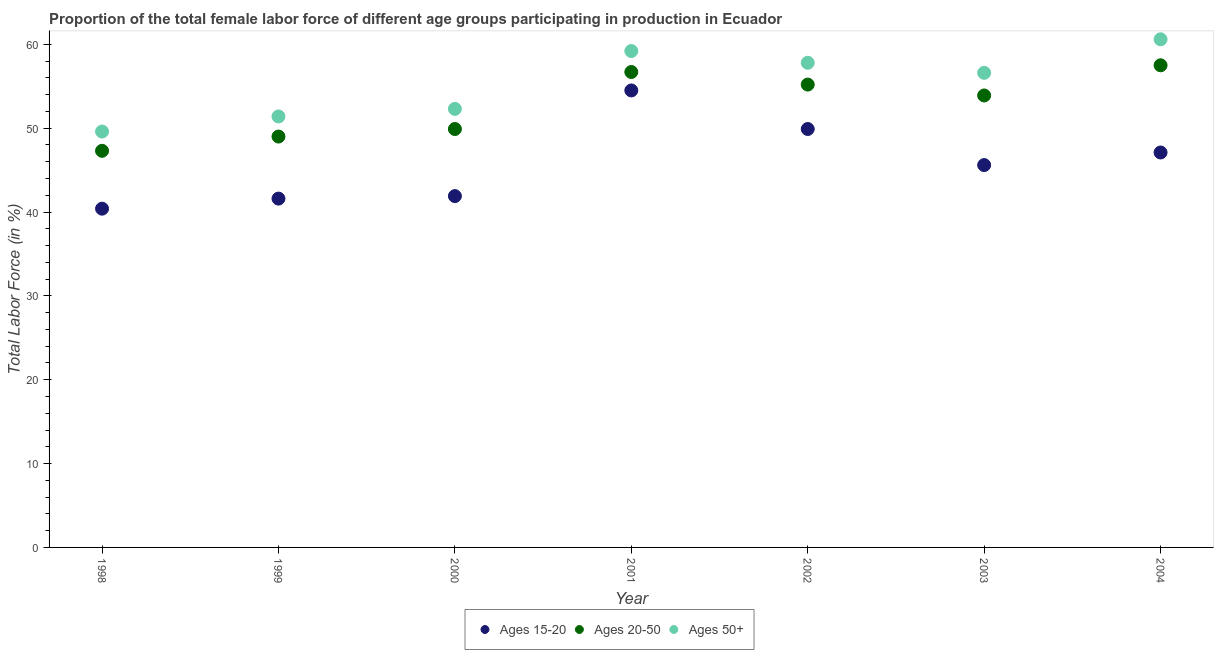Is the number of dotlines equal to the number of legend labels?
Ensure brevity in your answer.  Yes. What is the percentage of female labor force above age 50 in 1998?
Offer a very short reply. 49.6. Across all years, what is the maximum percentage of female labor force within the age group 20-50?
Provide a succinct answer. 57.5. Across all years, what is the minimum percentage of female labor force within the age group 20-50?
Give a very brief answer. 47.3. In which year was the percentage of female labor force above age 50 maximum?
Offer a terse response. 2004. In which year was the percentage of female labor force within the age group 15-20 minimum?
Offer a very short reply. 1998. What is the total percentage of female labor force above age 50 in the graph?
Make the answer very short. 387.5. What is the difference between the percentage of female labor force within the age group 20-50 in 1998 and that in 2002?
Offer a very short reply. -7.9. What is the difference between the percentage of female labor force above age 50 in 2000 and the percentage of female labor force within the age group 20-50 in 2004?
Your response must be concise. -5.2. What is the average percentage of female labor force within the age group 15-20 per year?
Give a very brief answer. 45.86. In the year 2001, what is the difference between the percentage of female labor force within the age group 20-50 and percentage of female labor force above age 50?
Keep it short and to the point. -2.5. What is the ratio of the percentage of female labor force above age 50 in 2002 to that in 2004?
Give a very brief answer. 0.95. What is the difference between the highest and the second highest percentage of female labor force within the age group 15-20?
Ensure brevity in your answer.  4.6. In how many years, is the percentage of female labor force within the age group 15-20 greater than the average percentage of female labor force within the age group 15-20 taken over all years?
Your response must be concise. 3. Is the percentage of female labor force within the age group 20-50 strictly greater than the percentage of female labor force above age 50 over the years?
Ensure brevity in your answer.  No. How many dotlines are there?
Provide a short and direct response. 3. How many years are there in the graph?
Provide a short and direct response. 7. What is the difference between two consecutive major ticks on the Y-axis?
Your answer should be very brief. 10. Are the values on the major ticks of Y-axis written in scientific E-notation?
Provide a short and direct response. No. How many legend labels are there?
Provide a succinct answer. 3. What is the title of the graph?
Give a very brief answer. Proportion of the total female labor force of different age groups participating in production in Ecuador. Does "Capital account" appear as one of the legend labels in the graph?
Provide a succinct answer. No. What is the Total Labor Force (in %) in Ages 15-20 in 1998?
Provide a succinct answer. 40.4. What is the Total Labor Force (in %) in Ages 20-50 in 1998?
Make the answer very short. 47.3. What is the Total Labor Force (in %) in Ages 50+ in 1998?
Offer a terse response. 49.6. What is the Total Labor Force (in %) of Ages 15-20 in 1999?
Ensure brevity in your answer.  41.6. What is the Total Labor Force (in %) of Ages 20-50 in 1999?
Offer a terse response. 49. What is the Total Labor Force (in %) in Ages 50+ in 1999?
Ensure brevity in your answer.  51.4. What is the Total Labor Force (in %) in Ages 15-20 in 2000?
Keep it short and to the point. 41.9. What is the Total Labor Force (in %) in Ages 20-50 in 2000?
Offer a very short reply. 49.9. What is the Total Labor Force (in %) in Ages 50+ in 2000?
Keep it short and to the point. 52.3. What is the Total Labor Force (in %) in Ages 15-20 in 2001?
Your answer should be compact. 54.5. What is the Total Labor Force (in %) in Ages 20-50 in 2001?
Keep it short and to the point. 56.7. What is the Total Labor Force (in %) of Ages 50+ in 2001?
Keep it short and to the point. 59.2. What is the Total Labor Force (in %) of Ages 15-20 in 2002?
Provide a succinct answer. 49.9. What is the Total Labor Force (in %) in Ages 20-50 in 2002?
Your response must be concise. 55.2. What is the Total Labor Force (in %) of Ages 50+ in 2002?
Offer a very short reply. 57.8. What is the Total Labor Force (in %) in Ages 15-20 in 2003?
Ensure brevity in your answer.  45.6. What is the Total Labor Force (in %) in Ages 20-50 in 2003?
Provide a short and direct response. 53.9. What is the Total Labor Force (in %) of Ages 50+ in 2003?
Provide a succinct answer. 56.6. What is the Total Labor Force (in %) in Ages 15-20 in 2004?
Offer a terse response. 47.1. What is the Total Labor Force (in %) in Ages 20-50 in 2004?
Offer a terse response. 57.5. What is the Total Labor Force (in %) in Ages 50+ in 2004?
Your response must be concise. 60.6. Across all years, what is the maximum Total Labor Force (in %) in Ages 15-20?
Provide a succinct answer. 54.5. Across all years, what is the maximum Total Labor Force (in %) of Ages 20-50?
Give a very brief answer. 57.5. Across all years, what is the maximum Total Labor Force (in %) in Ages 50+?
Your answer should be compact. 60.6. Across all years, what is the minimum Total Labor Force (in %) in Ages 15-20?
Provide a short and direct response. 40.4. Across all years, what is the minimum Total Labor Force (in %) in Ages 20-50?
Your answer should be compact. 47.3. Across all years, what is the minimum Total Labor Force (in %) in Ages 50+?
Keep it short and to the point. 49.6. What is the total Total Labor Force (in %) of Ages 15-20 in the graph?
Ensure brevity in your answer.  321. What is the total Total Labor Force (in %) in Ages 20-50 in the graph?
Your response must be concise. 369.5. What is the total Total Labor Force (in %) in Ages 50+ in the graph?
Your answer should be compact. 387.5. What is the difference between the Total Labor Force (in %) in Ages 15-20 in 1998 and that in 1999?
Your response must be concise. -1.2. What is the difference between the Total Labor Force (in %) in Ages 50+ in 1998 and that in 1999?
Offer a terse response. -1.8. What is the difference between the Total Labor Force (in %) in Ages 15-20 in 1998 and that in 2001?
Offer a terse response. -14.1. What is the difference between the Total Labor Force (in %) in Ages 20-50 in 1998 and that in 2001?
Ensure brevity in your answer.  -9.4. What is the difference between the Total Labor Force (in %) of Ages 15-20 in 1998 and that in 2002?
Make the answer very short. -9.5. What is the difference between the Total Labor Force (in %) of Ages 20-50 in 1998 and that in 2002?
Provide a succinct answer. -7.9. What is the difference between the Total Labor Force (in %) in Ages 50+ in 1998 and that in 2002?
Provide a short and direct response. -8.2. What is the difference between the Total Labor Force (in %) of Ages 15-20 in 1998 and that in 2003?
Provide a succinct answer. -5.2. What is the difference between the Total Labor Force (in %) of Ages 15-20 in 1998 and that in 2004?
Your response must be concise. -6.7. What is the difference between the Total Labor Force (in %) of Ages 50+ in 1998 and that in 2004?
Ensure brevity in your answer.  -11. What is the difference between the Total Labor Force (in %) of Ages 20-50 in 1999 and that in 2000?
Provide a short and direct response. -0.9. What is the difference between the Total Labor Force (in %) of Ages 20-50 in 1999 and that in 2001?
Make the answer very short. -7.7. What is the difference between the Total Labor Force (in %) in Ages 20-50 in 1999 and that in 2002?
Provide a short and direct response. -6.2. What is the difference between the Total Labor Force (in %) in Ages 50+ in 1999 and that in 2002?
Ensure brevity in your answer.  -6.4. What is the difference between the Total Labor Force (in %) of Ages 15-20 in 1999 and that in 2003?
Make the answer very short. -4. What is the difference between the Total Labor Force (in %) in Ages 50+ in 1999 and that in 2004?
Give a very brief answer. -9.2. What is the difference between the Total Labor Force (in %) in Ages 15-20 in 2000 and that in 2001?
Make the answer very short. -12.6. What is the difference between the Total Labor Force (in %) of Ages 15-20 in 2000 and that in 2002?
Your answer should be compact. -8. What is the difference between the Total Labor Force (in %) in Ages 20-50 in 2000 and that in 2002?
Offer a very short reply. -5.3. What is the difference between the Total Labor Force (in %) of Ages 50+ in 2000 and that in 2003?
Ensure brevity in your answer.  -4.3. What is the difference between the Total Labor Force (in %) in Ages 15-20 in 2000 and that in 2004?
Give a very brief answer. -5.2. What is the difference between the Total Labor Force (in %) of Ages 20-50 in 2000 and that in 2004?
Offer a terse response. -7.6. What is the difference between the Total Labor Force (in %) of Ages 20-50 in 2001 and that in 2002?
Give a very brief answer. 1.5. What is the difference between the Total Labor Force (in %) of Ages 50+ in 2001 and that in 2002?
Your answer should be compact. 1.4. What is the difference between the Total Labor Force (in %) of Ages 20-50 in 2001 and that in 2003?
Your answer should be compact. 2.8. What is the difference between the Total Labor Force (in %) of Ages 50+ in 2001 and that in 2003?
Your response must be concise. 2.6. What is the difference between the Total Labor Force (in %) in Ages 20-50 in 2001 and that in 2004?
Offer a very short reply. -0.8. What is the difference between the Total Labor Force (in %) in Ages 50+ in 2001 and that in 2004?
Ensure brevity in your answer.  -1.4. What is the difference between the Total Labor Force (in %) of Ages 15-20 in 2002 and that in 2003?
Offer a terse response. 4.3. What is the difference between the Total Labor Force (in %) in Ages 50+ in 2002 and that in 2003?
Give a very brief answer. 1.2. What is the difference between the Total Labor Force (in %) of Ages 15-20 in 2003 and that in 2004?
Give a very brief answer. -1.5. What is the difference between the Total Labor Force (in %) in Ages 50+ in 2003 and that in 2004?
Provide a succinct answer. -4. What is the difference between the Total Labor Force (in %) of Ages 15-20 in 1998 and the Total Labor Force (in %) of Ages 20-50 in 1999?
Your response must be concise. -8.6. What is the difference between the Total Labor Force (in %) of Ages 15-20 in 1998 and the Total Labor Force (in %) of Ages 50+ in 1999?
Give a very brief answer. -11. What is the difference between the Total Labor Force (in %) in Ages 15-20 in 1998 and the Total Labor Force (in %) in Ages 50+ in 2000?
Offer a very short reply. -11.9. What is the difference between the Total Labor Force (in %) of Ages 15-20 in 1998 and the Total Labor Force (in %) of Ages 20-50 in 2001?
Your answer should be very brief. -16.3. What is the difference between the Total Labor Force (in %) in Ages 15-20 in 1998 and the Total Labor Force (in %) in Ages 50+ in 2001?
Make the answer very short. -18.8. What is the difference between the Total Labor Force (in %) in Ages 20-50 in 1998 and the Total Labor Force (in %) in Ages 50+ in 2001?
Provide a succinct answer. -11.9. What is the difference between the Total Labor Force (in %) in Ages 15-20 in 1998 and the Total Labor Force (in %) in Ages 20-50 in 2002?
Make the answer very short. -14.8. What is the difference between the Total Labor Force (in %) in Ages 15-20 in 1998 and the Total Labor Force (in %) in Ages 50+ in 2002?
Give a very brief answer. -17.4. What is the difference between the Total Labor Force (in %) of Ages 20-50 in 1998 and the Total Labor Force (in %) of Ages 50+ in 2002?
Provide a short and direct response. -10.5. What is the difference between the Total Labor Force (in %) in Ages 15-20 in 1998 and the Total Labor Force (in %) in Ages 20-50 in 2003?
Your answer should be very brief. -13.5. What is the difference between the Total Labor Force (in %) in Ages 15-20 in 1998 and the Total Labor Force (in %) in Ages 50+ in 2003?
Your answer should be compact. -16.2. What is the difference between the Total Labor Force (in %) in Ages 20-50 in 1998 and the Total Labor Force (in %) in Ages 50+ in 2003?
Provide a short and direct response. -9.3. What is the difference between the Total Labor Force (in %) of Ages 15-20 in 1998 and the Total Labor Force (in %) of Ages 20-50 in 2004?
Keep it short and to the point. -17.1. What is the difference between the Total Labor Force (in %) in Ages 15-20 in 1998 and the Total Labor Force (in %) in Ages 50+ in 2004?
Your answer should be compact. -20.2. What is the difference between the Total Labor Force (in %) of Ages 15-20 in 1999 and the Total Labor Force (in %) of Ages 20-50 in 2000?
Provide a succinct answer. -8.3. What is the difference between the Total Labor Force (in %) in Ages 15-20 in 1999 and the Total Labor Force (in %) in Ages 50+ in 2000?
Provide a short and direct response. -10.7. What is the difference between the Total Labor Force (in %) in Ages 15-20 in 1999 and the Total Labor Force (in %) in Ages 20-50 in 2001?
Provide a short and direct response. -15.1. What is the difference between the Total Labor Force (in %) in Ages 15-20 in 1999 and the Total Labor Force (in %) in Ages 50+ in 2001?
Your answer should be very brief. -17.6. What is the difference between the Total Labor Force (in %) in Ages 20-50 in 1999 and the Total Labor Force (in %) in Ages 50+ in 2001?
Make the answer very short. -10.2. What is the difference between the Total Labor Force (in %) in Ages 15-20 in 1999 and the Total Labor Force (in %) in Ages 50+ in 2002?
Provide a succinct answer. -16.2. What is the difference between the Total Labor Force (in %) in Ages 15-20 in 1999 and the Total Labor Force (in %) in Ages 50+ in 2003?
Keep it short and to the point. -15. What is the difference between the Total Labor Force (in %) of Ages 15-20 in 1999 and the Total Labor Force (in %) of Ages 20-50 in 2004?
Provide a short and direct response. -15.9. What is the difference between the Total Labor Force (in %) of Ages 15-20 in 2000 and the Total Labor Force (in %) of Ages 20-50 in 2001?
Provide a succinct answer. -14.8. What is the difference between the Total Labor Force (in %) of Ages 15-20 in 2000 and the Total Labor Force (in %) of Ages 50+ in 2001?
Provide a succinct answer. -17.3. What is the difference between the Total Labor Force (in %) of Ages 15-20 in 2000 and the Total Labor Force (in %) of Ages 20-50 in 2002?
Give a very brief answer. -13.3. What is the difference between the Total Labor Force (in %) of Ages 15-20 in 2000 and the Total Labor Force (in %) of Ages 50+ in 2002?
Your answer should be compact. -15.9. What is the difference between the Total Labor Force (in %) in Ages 15-20 in 2000 and the Total Labor Force (in %) in Ages 50+ in 2003?
Keep it short and to the point. -14.7. What is the difference between the Total Labor Force (in %) of Ages 15-20 in 2000 and the Total Labor Force (in %) of Ages 20-50 in 2004?
Your response must be concise. -15.6. What is the difference between the Total Labor Force (in %) of Ages 15-20 in 2000 and the Total Labor Force (in %) of Ages 50+ in 2004?
Provide a succinct answer. -18.7. What is the difference between the Total Labor Force (in %) in Ages 20-50 in 2000 and the Total Labor Force (in %) in Ages 50+ in 2004?
Give a very brief answer. -10.7. What is the difference between the Total Labor Force (in %) of Ages 15-20 in 2001 and the Total Labor Force (in %) of Ages 20-50 in 2002?
Offer a terse response. -0.7. What is the difference between the Total Labor Force (in %) in Ages 15-20 in 2001 and the Total Labor Force (in %) in Ages 50+ in 2002?
Offer a terse response. -3.3. What is the difference between the Total Labor Force (in %) in Ages 15-20 in 2001 and the Total Labor Force (in %) in Ages 20-50 in 2003?
Your answer should be very brief. 0.6. What is the difference between the Total Labor Force (in %) of Ages 20-50 in 2001 and the Total Labor Force (in %) of Ages 50+ in 2003?
Keep it short and to the point. 0.1. What is the difference between the Total Labor Force (in %) in Ages 20-50 in 2001 and the Total Labor Force (in %) in Ages 50+ in 2004?
Your answer should be compact. -3.9. What is the difference between the Total Labor Force (in %) of Ages 15-20 in 2003 and the Total Labor Force (in %) of Ages 20-50 in 2004?
Your answer should be compact. -11.9. What is the difference between the Total Labor Force (in %) of Ages 15-20 in 2003 and the Total Labor Force (in %) of Ages 50+ in 2004?
Your answer should be very brief. -15. What is the difference between the Total Labor Force (in %) in Ages 20-50 in 2003 and the Total Labor Force (in %) in Ages 50+ in 2004?
Your answer should be compact. -6.7. What is the average Total Labor Force (in %) of Ages 15-20 per year?
Give a very brief answer. 45.86. What is the average Total Labor Force (in %) of Ages 20-50 per year?
Make the answer very short. 52.79. What is the average Total Labor Force (in %) in Ages 50+ per year?
Keep it short and to the point. 55.36. In the year 1998, what is the difference between the Total Labor Force (in %) of Ages 15-20 and Total Labor Force (in %) of Ages 20-50?
Ensure brevity in your answer.  -6.9. In the year 1998, what is the difference between the Total Labor Force (in %) in Ages 15-20 and Total Labor Force (in %) in Ages 50+?
Offer a terse response. -9.2. In the year 1998, what is the difference between the Total Labor Force (in %) of Ages 20-50 and Total Labor Force (in %) of Ages 50+?
Provide a succinct answer. -2.3. In the year 1999, what is the difference between the Total Labor Force (in %) in Ages 15-20 and Total Labor Force (in %) in Ages 20-50?
Offer a very short reply. -7.4. In the year 1999, what is the difference between the Total Labor Force (in %) in Ages 15-20 and Total Labor Force (in %) in Ages 50+?
Your response must be concise. -9.8. In the year 2000, what is the difference between the Total Labor Force (in %) in Ages 15-20 and Total Labor Force (in %) in Ages 50+?
Give a very brief answer. -10.4. In the year 2001, what is the difference between the Total Labor Force (in %) in Ages 15-20 and Total Labor Force (in %) in Ages 20-50?
Keep it short and to the point. -2.2. In the year 2001, what is the difference between the Total Labor Force (in %) in Ages 15-20 and Total Labor Force (in %) in Ages 50+?
Provide a short and direct response. -4.7. In the year 2002, what is the difference between the Total Labor Force (in %) of Ages 20-50 and Total Labor Force (in %) of Ages 50+?
Ensure brevity in your answer.  -2.6. In the year 2003, what is the difference between the Total Labor Force (in %) in Ages 15-20 and Total Labor Force (in %) in Ages 50+?
Your response must be concise. -11. In the year 2003, what is the difference between the Total Labor Force (in %) of Ages 20-50 and Total Labor Force (in %) of Ages 50+?
Provide a short and direct response. -2.7. In the year 2004, what is the difference between the Total Labor Force (in %) in Ages 20-50 and Total Labor Force (in %) in Ages 50+?
Provide a succinct answer. -3.1. What is the ratio of the Total Labor Force (in %) in Ages 15-20 in 1998 to that in 1999?
Your answer should be very brief. 0.97. What is the ratio of the Total Labor Force (in %) of Ages 20-50 in 1998 to that in 1999?
Your answer should be very brief. 0.97. What is the ratio of the Total Labor Force (in %) of Ages 50+ in 1998 to that in 1999?
Offer a terse response. 0.96. What is the ratio of the Total Labor Force (in %) of Ages 15-20 in 1998 to that in 2000?
Provide a succinct answer. 0.96. What is the ratio of the Total Labor Force (in %) of Ages 20-50 in 1998 to that in 2000?
Your answer should be very brief. 0.95. What is the ratio of the Total Labor Force (in %) in Ages 50+ in 1998 to that in 2000?
Offer a very short reply. 0.95. What is the ratio of the Total Labor Force (in %) in Ages 15-20 in 1998 to that in 2001?
Provide a short and direct response. 0.74. What is the ratio of the Total Labor Force (in %) in Ages 20-50 in 1998 to that in 2001?
Make the answer very short. 0.83. What is the ratio of the Total Labor Force (in %) of Ages 50+ in 1998 to that in 2001?
Keep it short and to the point. 0.84. What is the ratio of the Total Labor Force (in %) in Ages 15-20 in 1998 to that in 2002?
Offer a terse response. 0.81. What is the ratio of the Total Labor Force (in %) of Ages 20-50 in 1998 to that in 2002?
Provide a short and direct response. 0.86. What is the ratio of the Total Labor Force (in %) of Ages 50+ in 1998 to that in 2002?
Give a very brief answer. 0.86. What is the ratio of the Total Labor Force (in %) of Ages 15-20 in 1998 to that in 2003?
Offer a terse response. 0.89. What is the ratio of the Total Labor Force (in %) in Ages 20-50 in 1998 to that in 2003?
Your answer should be compact. 0.88. What is the ratio of the Total Labor Force (in %) in Ages 50+ in 1998 to that in 2003?
Make the answer very short. 0.88. What is the ratio of the Total Labor Force (in %) of Ages 15-20 in 1998 to that in 2004?
Your answer should be compact. 0.86. What is the ratio of the Total Labor Force (in %) in Ages 20-50 in 1998 to that in 2004?
Your response must be concise. 0.82. What is the ratio of the Total Labor Force (in %) in Ages 50+ in 1998 to that in 2004?
Offer a terse response. 0.82. What is the ratio of the Total Labor Force (in %) of Ages 15-20 in 1999 to that in 2000?
Your response must be concise. 0.99. What is the ratio of the Total Labor Force (in %) of Ages 20-50 in 1999 to that in 2000?
Give a very brief answer. 0.98. What is the ratio of the Total Labor Force (in %) of Ages 50+ in 1999 to that in 2000?
Make the answer very short. 0.98. What is the ratio of the Total Labor Force (in %) in Ages 15-20 in 1999 to that in 2001?
Ensure brevity in your answer.  0.76. What is the ratio of the Total Labor Force (in %) of Ages 20-50 in 1999 to that in 2001?
Ensure brevity in your answer.  0.86. What is the ratio of the Total Labor Force (in %) of Ages 50+ in 1999 to that in 2001?
Make the answer very short. 0.87. What is the ratio of the Total Labor Force (in %) in Ages 15-20 in 1999 to that in 2002?
Provide a succinct answer. 0.83. What is the ratio of the Total Labor Force (in %) of Ages 20-50 in 1999 to that in 2002?
Offer a very short reply. 0.89. What is the ratio of the Total Labor Force (in %) of Ages 50+ in 1999 to that in 2002?
Provide a succinct answer. 0.89. What is the ratio of the Total Labor Force (in %) of Ages 15-20 in 1999 to that in 2003?
Make the answer very short. 0.91. What is the ratio of the Total Labor Force (in %) of Ages 20-50 in 1999 to that in 2003?
Make the answer very short. 0.91. What is the ratio of the Total Labor Force (in %) in Ages 50+ in 1999 to that in 2003?
Offer a terse response. 0.91. What is the ratio of the Total Labor Force (in %) in Ages 15-20 in 1999 to that in 2004?
Provide a succinct answer. 0.88. What is the ratio of the Total Labor Force (in %) in Ages 20-50 in 1999 to that in 2004?
Offer a very short reply. 0.85. What is the ratio of the Total Labor Force (in %) in Ages 50+ in 1999 to that in 2004?
Ensure brevity in your answer.  0.85. What is the ratio of the Total Labor Force (in %) of Ages 15-20 in 2000 to that in 2001?
Keep it short and to the point. 0.77. What is the ratio of the Total Labor Force (in %) of Ages 20-50 in 2000 to that in 2001?
Provide a short and direct response. 0.88. What is the ratio of the Total Labor Force (in %) in Ages 50+ in 2000 to that in 2001?
Your answer should be very brief. 0.88. What is the ratio of the Total Labor Force (in %) of Ages 15-20 in 2000 to that in 2002?
Ensure brevity in your answer.  0.84. What is the ratio of the Total Labor Force (in %) in Ages 20-50 in 2000 to that in 2002?
Make the answer very short. 0.9. What is the ratio of the Total Labor Force (in %) in Ages 50+ in 2000 to that in 2002?
Your answer should be compact. 0.9. What is the ratio of the Total Labor Force (in %) of Ages 15-20 in 2000 to that in 2003?
Your response must be concise. 0.92. What is the ratio of the Total Labor Force (in %) of Ages 20-50 in 2000 to that in 2003?
Provide a succinct answer. 0.93. What is the ratio of the Total Labor Force (in %) of Ages 50+ in 2000 to that in 2003?
Ensure brevity in your answer.  0.92. What is the ratio of the Total Labor Force (in %) of Ages 15-20 in 2000 to that in 2004?
Provide a succinct answer. 0.89. What is the ratio of the Total Labor Force (in %) in Ages 20-50 in 2000 to that in 2004?
Offer a very short reply. 0.87. What is the ratio of the Total Labor Force (in %) of Ages 50+ in 2000 to that in 2004?
Make the answer very short. 0.86. What is the ratio of the Total Labor Force (in %) of Ages 15-20 in 2001 to that in 2002?
Make the answer very short. 1.09. What is the ratio of the Total Labor Force (in %) in Ages 20-50 in 2001 to that in 2002?
Your answer should be compact. 1.03. What is the ratio of the Total Labor Force (in %) in Ages 50+ in 2001 to that in 2002?
Offer a terse response. 1.02. What is the ratio of the Total Labor Force (in %) of Ages 15-20 in 2001 to that in 2003?
Your answer should be very brief. 1.2. What is the ratio of the Total Labor Force (in %) in Ages 20-50 in 2001 to that in 2003?
Your response must be concise. 1.05. What is the ratio of the Total Labor Force (in %) in Ages 50+ in 2001 to that in 2003?
Your answer should be compact. 1.05. What is the ratio of the Total Labor Force (in %) of Ages 15-20 in 2001 to that in 2004?
Your answer should be compact. 1.16. What is the ratio of the Total Labor Force (in %) in Ages 20-50 in 2001 to that in 2004?
Provide a short and direct response. 0.99. What is the ratio of the Total Labor Force (in %) of Ages 50+ in 2001 to that in 2004?
Keep it short and to the point. 0.98. What is the ratio of the Total Labor Force (in %) in Ages 15-20 in 2002 to that in 2003?
Provide a succinct answer. 1.09. What is the ratio of the Total Labor Force (in %) of Ages 20-50 in 2002 to that in 2003?
Your answer should be compact. 1.02. What is the ratio of the Total Labor Force (in %) of Ages 50+ in 2002 to that in 2003?
Ensure brevity in your answer.  1.02. What is the ratio of the Total Labor Force (in %) of Ages 15-20 in 2002 to that in 2004?
Provide a short and direct response. 1.06. What is the ratio of the Total Labor Force (in %) in Ages 50+ in 2002 to that in 2004?
Offer a terse response. 0.95. What is the ratio of the Total Labor Force (in %) of Ages 15-20 in 2003 to that in 2004?
Keep it short and to the point. 0.97. What is the ratio of the Total Labor Force (in %) in Ages 20-50 in 2003 to that in 2004?
Ensure brevity in your answer.  0.94. What is the ratio of the Total Labor Force (in %) of Ages 50+ in 2003 to that in 2004?
Give a very brief answer. 0.93. What is the difference between the highest and the second highest Total Labor Force (in %) of Ages 15-20?
Keep it short and to the point. 4.6. What is the difference between the highest and the second highest Total Labor Force (in %) in Ages 20-50?
Offer a very short reply. 0.8. What is the difference between the highest and the lowest Total Labor Force (in %) in Ages 15-20?
Offer a very short reply. 14.1. What is the difference between the highest and the lowest Total Labor Force (in %) of Ages 20-50?
Your answer should be compact. 10.2. What is the difference between the highest and the lowest Total Labor Force (in %) of Ages 50+?
Provide a short and direct response. 11. 